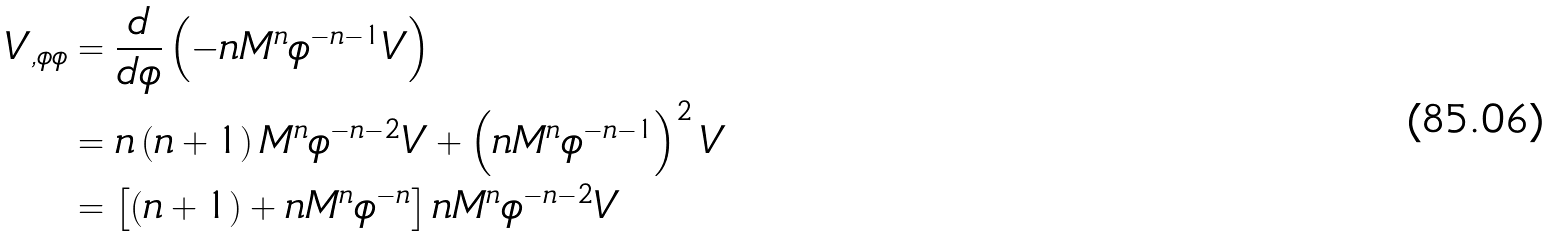<formula> <loc_0><loc_0><loc_500><loc_500>V _ { , \phi \phi } & = \frac { d } { d \phi } \left ( - n M ^ { n } \phi ^ { - n - 1 } V \right ) \\ & = n \left ( n + 1 \right ) M ^ { n } \phi ^ { - n - 2 } V + \left ( n M ^ { n } \phi ^ { - n - 1 } \right ) ^ { 2 } V \\ & = \left [ \left ( n + 1 \right ) + n M ^ { n } \phi ^ { - n } \right ] n M ^ { n } \phi ^ { - n - 2 } V</formula> 